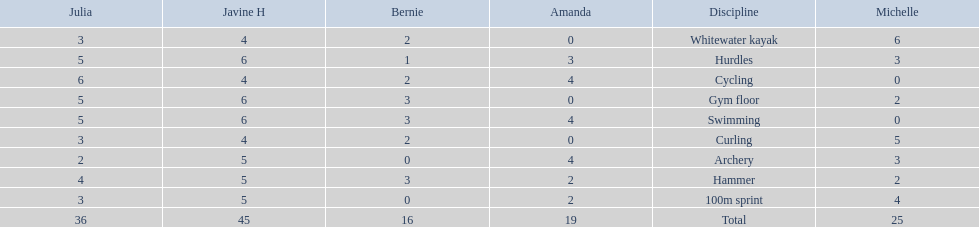Who scored the least on whitewater kayak? Amanda. 